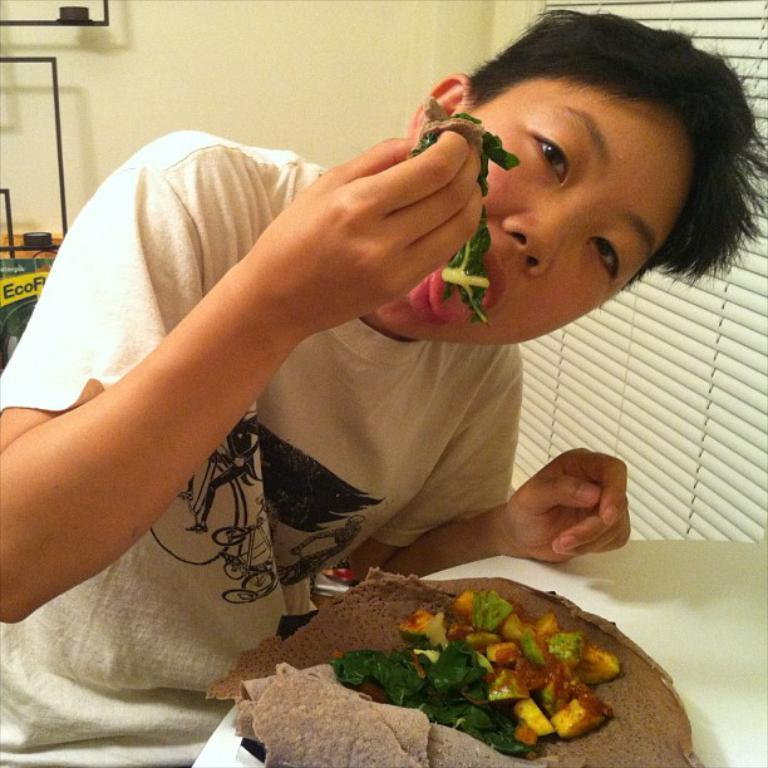What is the color of the table in the image? The table in the image is white. Who is sitting at the table? A boy is sitting at the table. What is the boy doing at the table? The boy is eating food. What can be seen in the background of the image? There is a white color wall in the background of the image. Can you see a garden, truck, or road in the image? No, there is no garden, truck, or road visible in the image. 